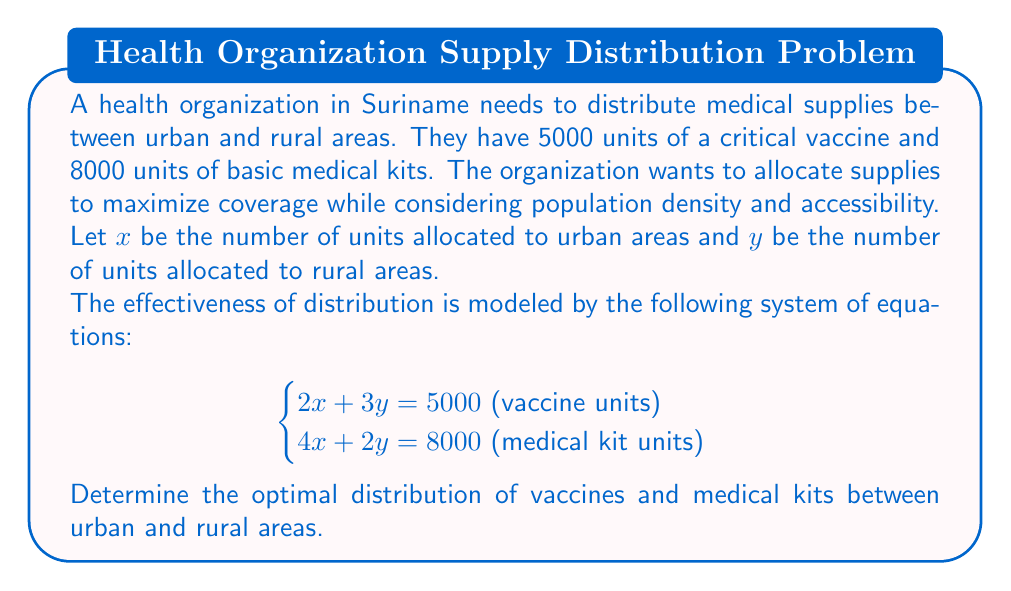Could you help me with this problem? To solve this system of equations, we'll use the substitution method:

1) From the first equation, express $y$ in terms of $x$:
   $$2x + 3y = 5000$$
   $$3y = 5000 - 2x$$
   $$y = \frac{5000 - 2x}{3}$$

2) Substitute this expression for $y$ into the second equation:
   $$4x + 2(\frac{5000 - 2x}{3}) = 8000$$

3) Simplify:
   $$4x + \frac{10000 - 4x}{3} = 8000$$
   $$12x + 10000 - 4x = 24000$$
   $$8x + 10000 = 24000$$
   $$8x = 14000$$
   $$x = 1750$$

4) Now that we know $x$, substitute back to find $y$:
   $$y = \frac{5000 - 2(1750)}{3} = \frac{5000 - 3500}{3} = \frac{1500}{3} = 500$$

5) Check the solution in both original equations:
   For vaccine units: $2(1750) + 3(500) = 3500 + 1500 = 5000$
   For medical kit units: $4(1750) + 2(500) = 7000 + 1000 = 8000$

Therefore, the optimal distribution is 1750 units to urban areas and 500 units to rural areas for both vaccines and medical kits.
Answer: Urban areas: 1750 units of vaccines and 1750 units of medical kits
Rural areas: 500 units of vaccines and 500 units of medical kits 